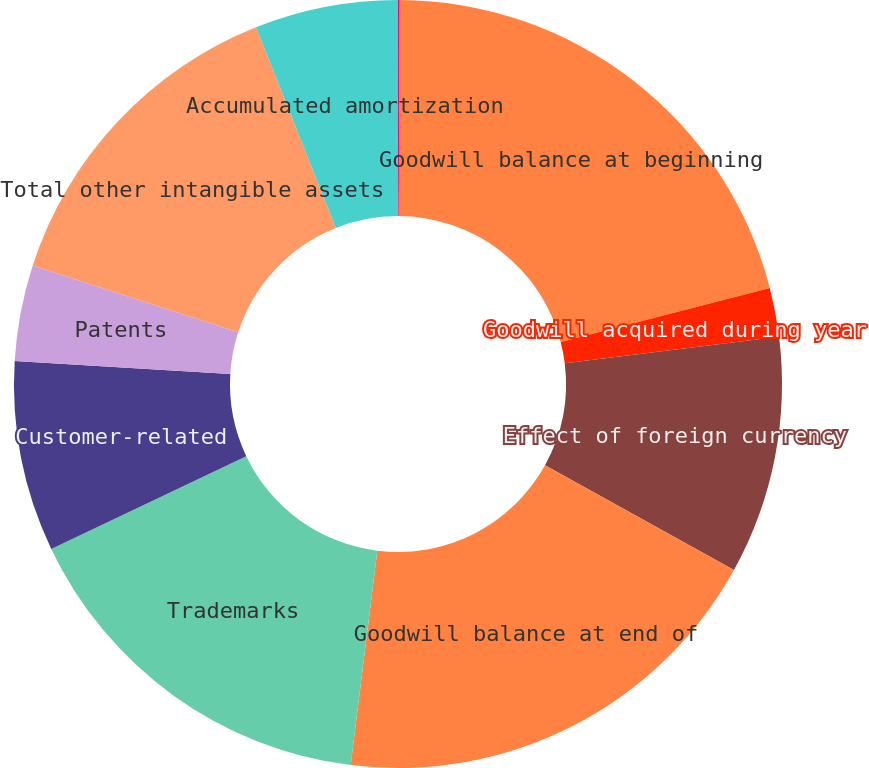<chart> <loc_0><loc_0><loc_500><loc_500><pie_chart><fcel>December 31<fcel>Goodwill balance at beginning<fcel>Goodwill acquired during year<fcel>Effect of foreign currency<fcel>Goodwill balance at end of<fcel>Trademarks<fcel>Customer-related<fcel>Patents<fcel>Total other intangible assets<fcel>Accumulated amortization<nl><fcel>0.07%<fcel>20.91%<fcel>2.06%<fcel>10.01%<fcel>18.92%<fcel>15.97%<fcel>8.02%<fcel>4.04%<fcel>13.98%<fcel>6.03%<nl></chart> 